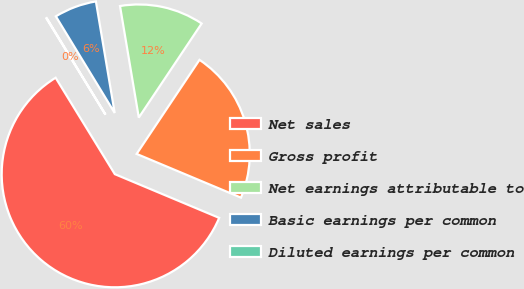Convert chart to OTSL. <chart><loc_0><loc_0><loc_500><loc_500><pie_chart><fcel>Net sales<fcel>Gross profit<fcel>Net earnings attributable to<fcel>Basic earnings per common<fcel>Diluted earnings per common<nl><fcel>59.92%<fcel>21.94%<fcel>12.03%<fcel>6.05%<fcel>0.06%<nl></chart> 